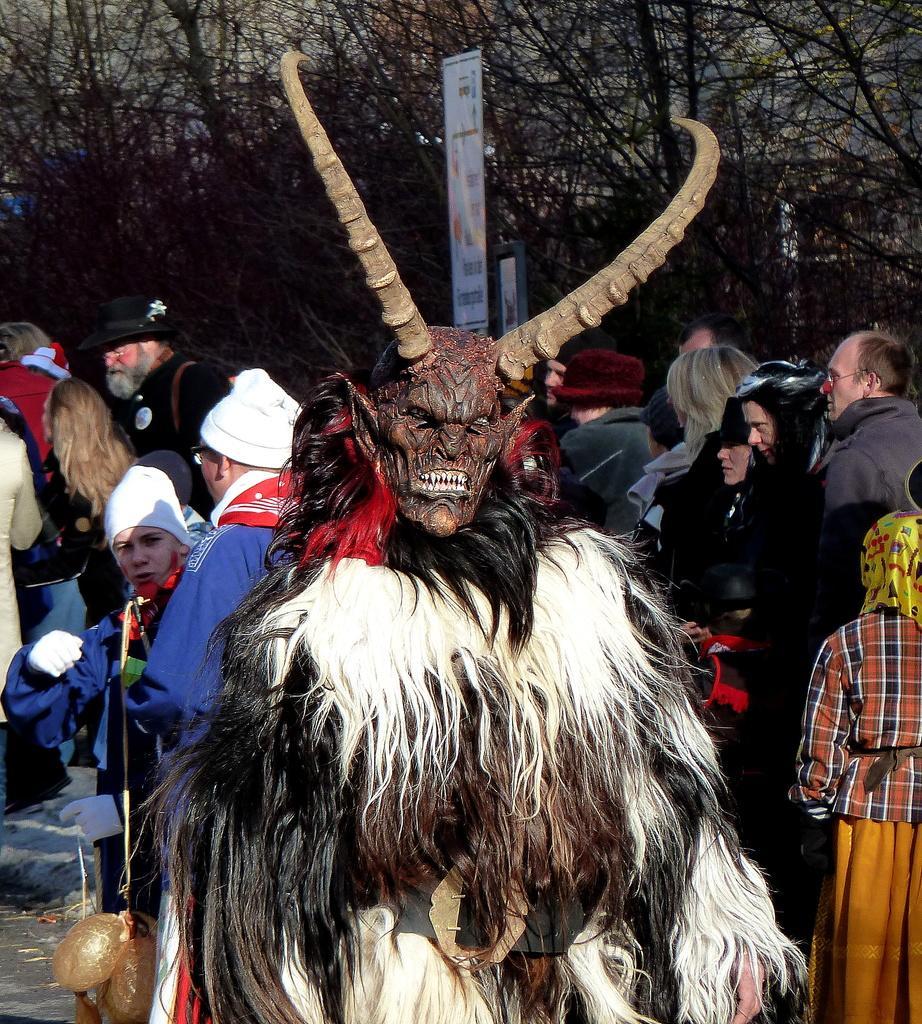Please provide a concise description of this image. In this image we can see a person wearing different types of costume is standing, behind them there are some other people standing on the road. In the background of the image there are trees. 